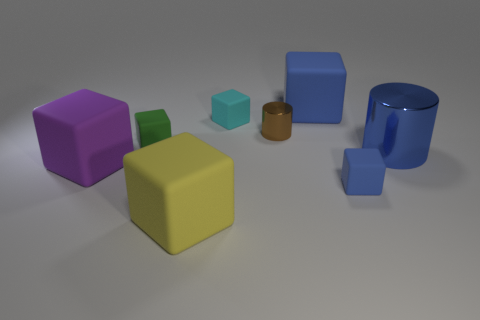Subtract all purple cubes. How many cubes are left? 5 Subtract all green cubes. How many cubes are left? 5 Subtract all gray cubes. Subtract all gray cylinders. How many cubes are left? 6 Add 1 small green metal cubes. How many objects exist? 9 Subtract all cubes. How many objects are left? 2 Subtract 0 red cylinders. How many objects are left? 8 Subtract all big green metal spheres. Subtract all small cyan cubes. How many objects are left? 7 Add 1 green cubes. How many green cubes are left? 2 Add 5 tiny objects. How many tiny objects exist? 9 